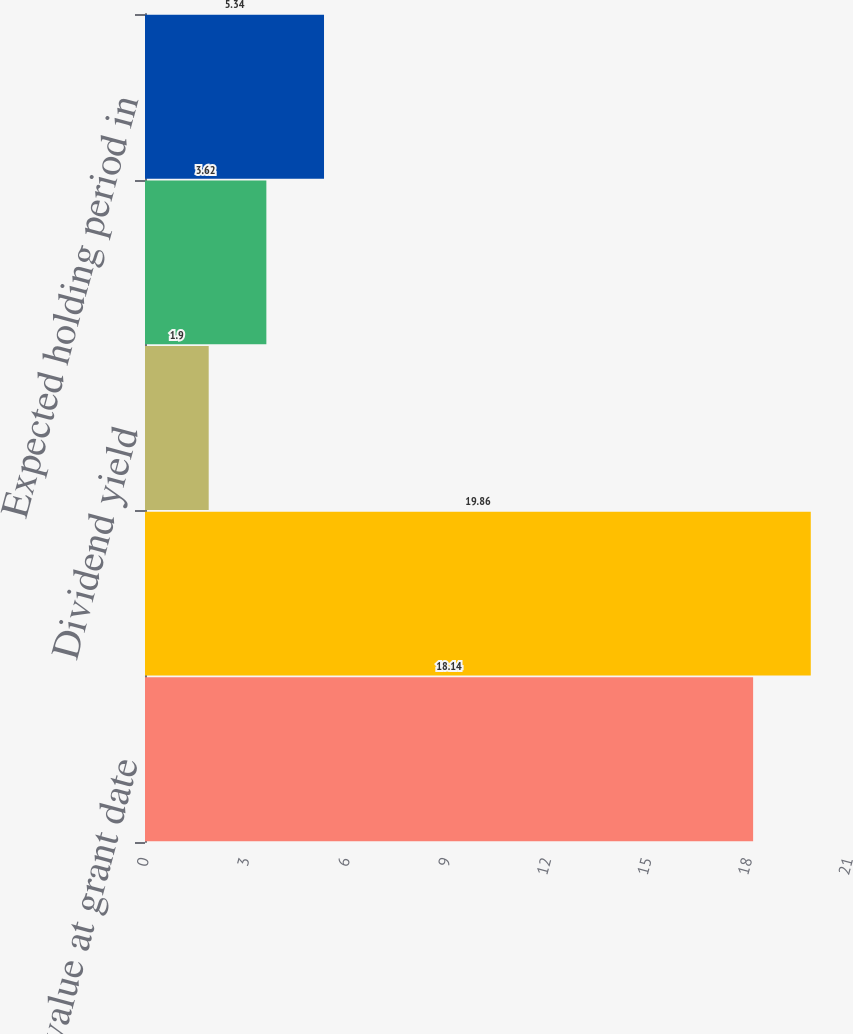Convert chart to OTSL. <chart><loc_0><loc_0><loc_500><loc_500><bar_chart><fcel>Fair value at grant date<fcel>Expected volatility<fcel>Dividend yield<fcel>Risk-free interest rate<fcel>Expected holding period in<nl><fcel>18.14<fcel>19.86<fcel>1.9<fcel>3.62<fcel>5.34<nl></chart> 